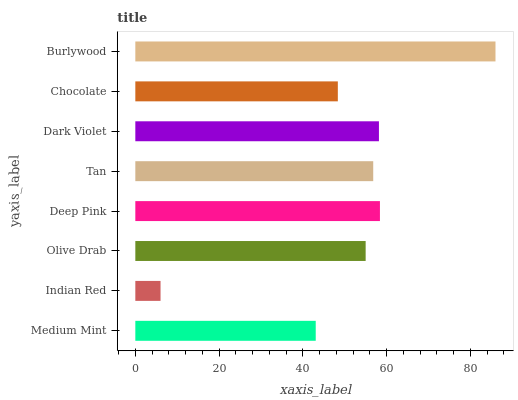Is Indian Red the minimum?
Answer yes or no. Yes. Is Burlywood the maximum?
Answer yes or no. Yes. Is Olive Drab the minimum?
Answer yes or no. No. Is Olive Drab the maximum?
Answer yes or no. No. Is Olive Drab greater than Indian Red?
Answer yes or no. Yes. Is Indian Red less than Olive Drab?
Answer yes or no. Yes. Is Indian Red greater than Olive Drab?
Answer yes or no. No. Is Olive Drab less than Indian Red?
Answer yes or no. No. Is Tan the high median?
Answer yes or no. Yes. Is Olive Drab the low median?
Answer yes or no. Yes. Is Indian Red the high median?
Answer yes or no. No. Is Dark Violet the low median?
Answer yes or no. No. 